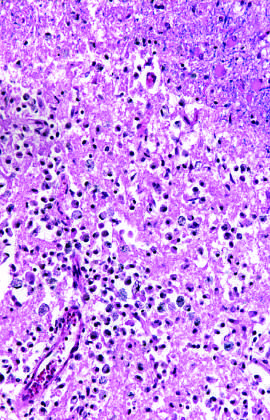re old intracortical infarcts seen as areas of tissue loss and residual gliosis?
Answer the question using a single word or phrase. Yes 